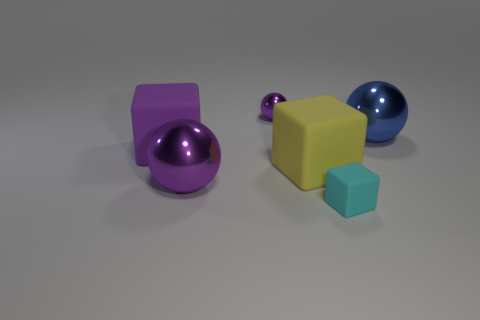Subtract all large cubes. How many cubes are left? 1 Add 3 big matte cylinders. How many objects exist? 9 Subtract all purple balls. How many balls are left? 1 Subtract 1 blocks. How many blocks are left? 2 Subtract all yellow cylinders. How many purple spheres are left? 2 Add 4 big purple matte blocks. How many big purple matte blocks exist? 5 Subtract 1 purple cubes. How many objects are left? 5 Subtract all red balls. Subtract all yellow cubes. How many balls are left? 3 Subtract all cyan blocks. Subtract all large purple rubber objects. How many objects are left? 4 Add 1 tiny purple objects. How many tiny purple objects are left? 2 